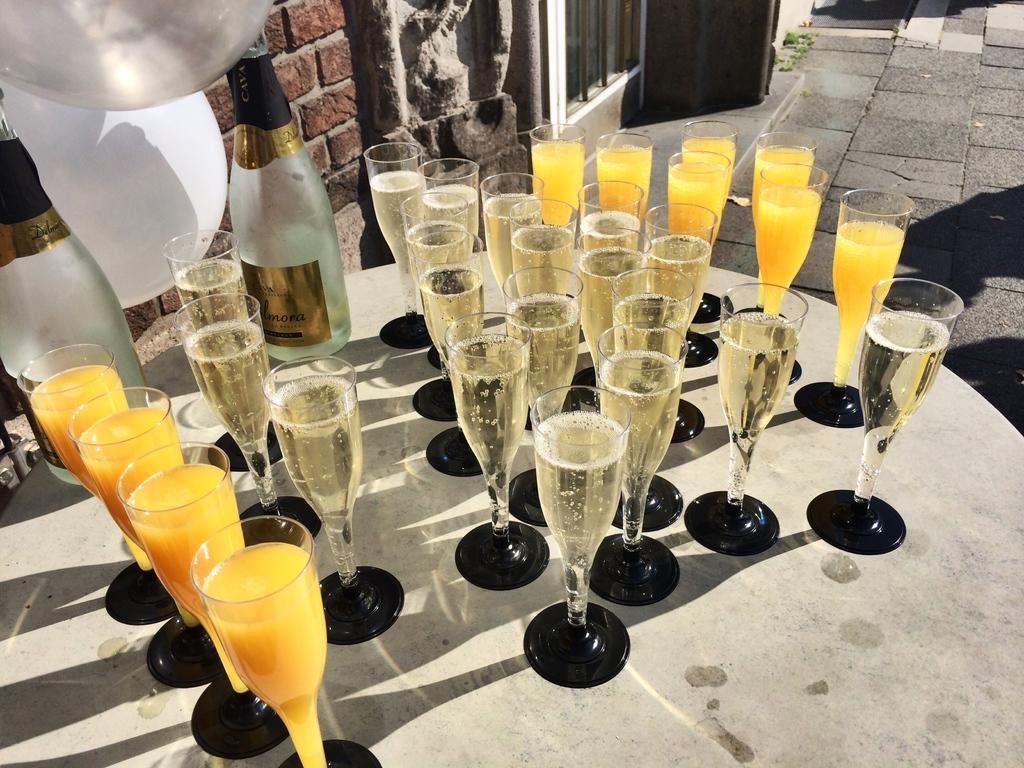How would you summarize this image in a sentence or two? In the center we can see table,on table we can see juice glasses,wine glasses and wine bottles. In the background there is a brick wall,balloon,grass and door. 